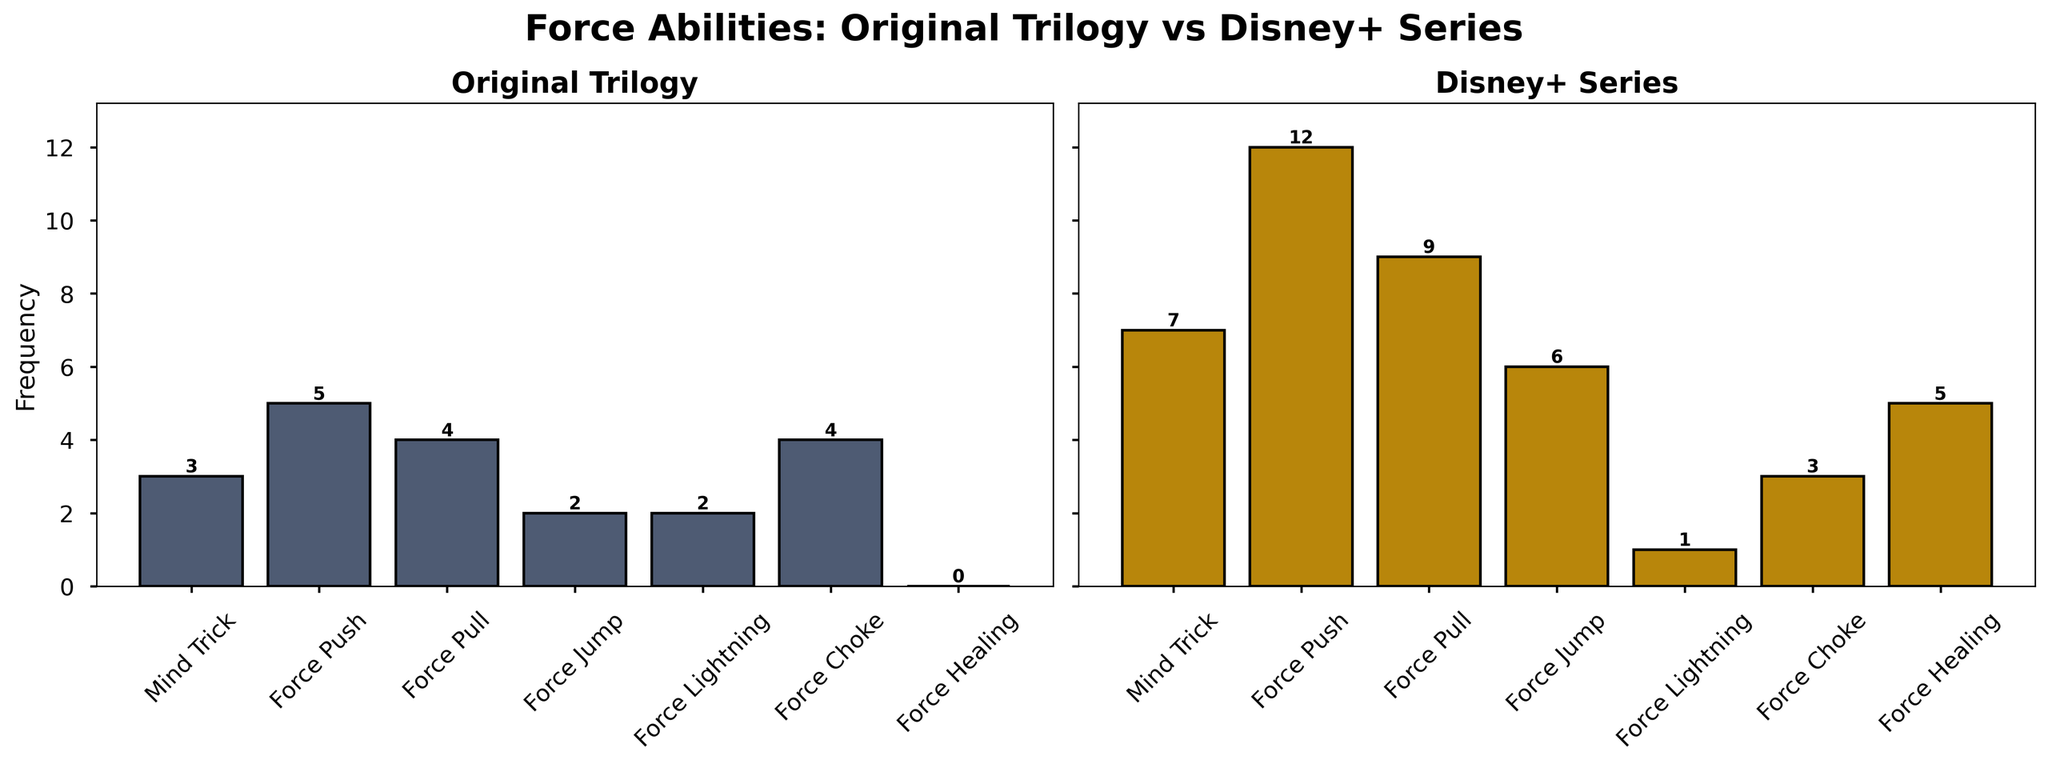How many more times is the Mind Trick used in the Disney+ series compared to the Original Trilogy? According to the figure, the Mind Trick is used 7 times in the Disney+ series and 3 times in the Original Trilogy. To find the difference, subtract the Original Trilogy count from the Disney+ count: 7 - 3 = 4
Answer: 4 Which Force-related ability is used most frequently in the Disney+ series? Looking at the Disney+ series chart, the Force Push shows the highest bar among all abilities, with a count of 12
Answer: Force Push How many total Force-related abilities are there in both series combined? Sum the total occurrences for both series: Original Trilogy (3 + 5 + 4 + 2 + 2 + 4 + 0) = 20, Disney+ Series (7 + 12 + 9 + 6 + 1 + 3 + 5) = 43. Combine the sums: 20 + 43 = 63
Answer: 63 Which ability shows a decrease in frequency from the Original Trilogy to the Disney+ series? Compare the heights of the bars in both charts: Force Lightning decreases from 2 to 1, and Force Choke decreases from 4 to 3
Answer: Force Lightning, Force Choke What is the ratio of Force Healing usage in the Disney+ series compared to the Original Trilogy? Force Healing is used 5 times in the Disney+ series and 0 times in the Original Trilogy. Since the Original Trilogy usage is 0, the ratio is undefined
Answer: Undefined Is the overall usage of Force-related abilities higher in the Disney+ series compared to the Original Trilogy? Sum the total occurrences for both series: Original Trilogy (3 + 5 + 4 + 2 + 2 + 4 + 0) = 20, Disney+ Series (7 + 12 + 9 + 6 + 1 + 3 + 5) = 43. The Disney+ series sum is higher
Answer: Yes What is the difference in Force Push usage between the two series? The figure shows that Force Push is used 12 times in the Disney+ series and 5 times in the Original Trilogy. Calculate the difference: 12 - 5 = 7
Answer: 7 Which ability is used equally in both the Original Trilogy and Disney+ series? Compare the bars for each ability in both charts: No ability has equal counts across both series. All abilities have varying counts.
Answer: None How much more frequently is Force Healing used in the Disney+ series than Force Choke in the Original Trilogy? Force Healing has a count of 5 in the Disney+ series, and Force Choke has a count of 4 in the Original Trilogy. To find the difference: 5 - 4 = 1
Answer: 1 Overall, which individual Force-related ability is used the least across both series? Force Healing in the Original Trilogy, with a count of 0, is the least used ability overall
Answer: Force Healing 